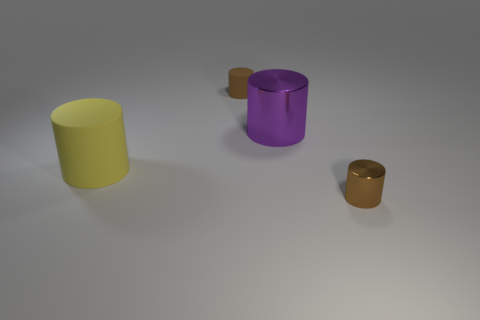Add 3 yellow cylinders. How many objects exist? 7 Subtract all tiny rubber objects. Subtract all brown metallic objects. How many objects are left? 2 Add 3 brown rubber cylinders. How many brown rubber cylinders are left? 4 Add 1 brown things. How many brown things exist? 3 Subtract 0 green cylinders. How many objects are left? 4 